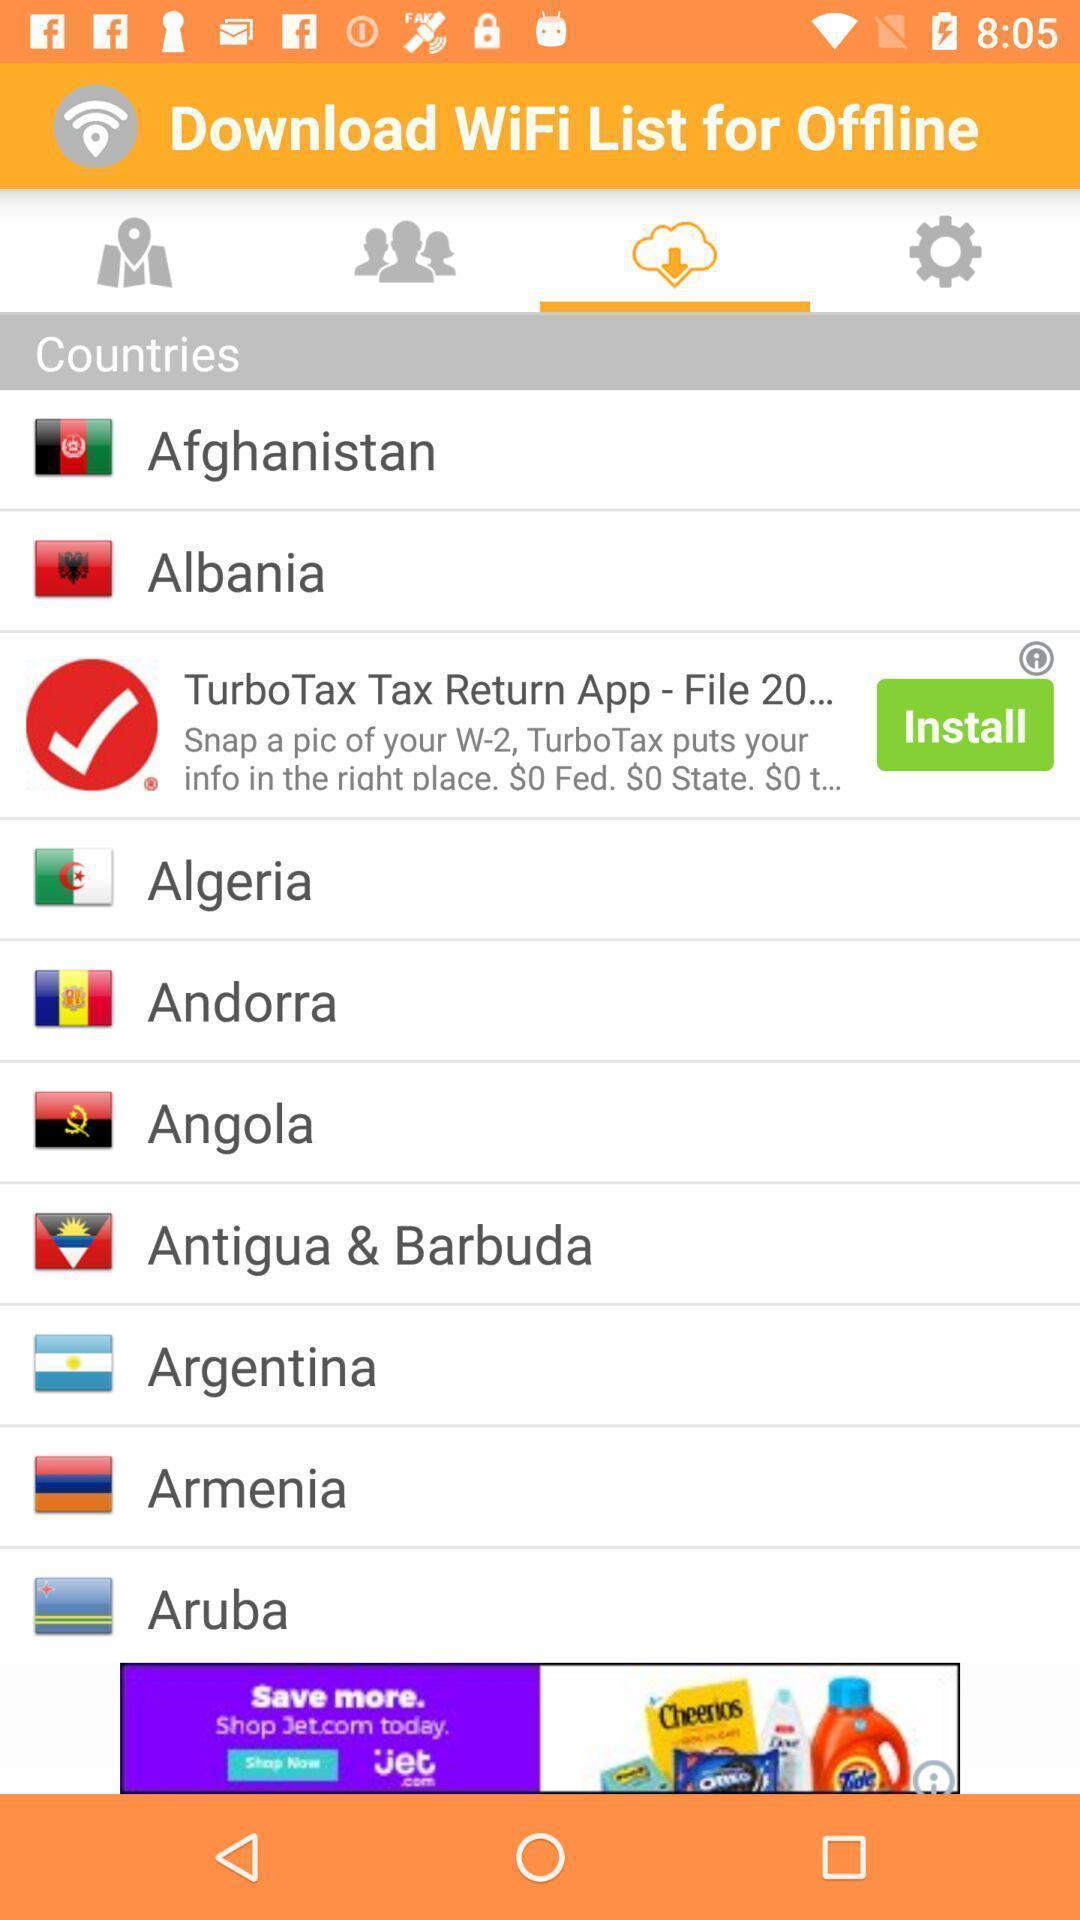Provide a description of this screenshot. List of options for downloading wifi in offline. 